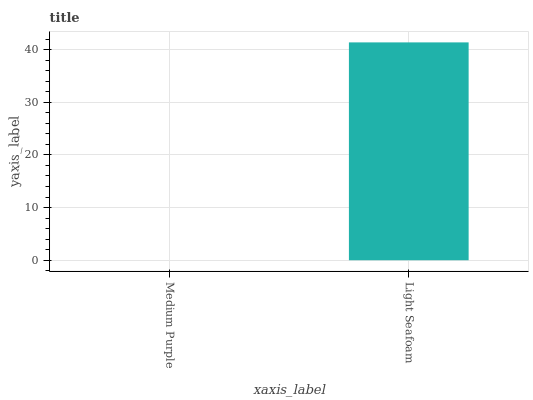Is Medium Purple the minimum?
Answer yes or no. Yes. Is Light Seafoam the maximum?
Answer yes or no. Yes. Is Light Seafoam the minimum?
Answer yes or no. No. Is Light Seafoam greater than Medium Purple?
Answer yes or no. Yes. Is Medium Purple less than Light Seafoam?
Answer yes or no. Yes. Is Medium Purple greater than Light Seafoam?
Answer yes or no. No. Is Light Seafoam less than Medium Purple?
Answer yes or no. No. Is Light Seafoam the high median?
Answer yes or no. Yes. Is Medium Purple the low median?
Answer yes or no. Yes. Is Medium Purple the high median?
Answer yes or no. No. Is Light Seafoam the low median?
Answer yes or no. No. 